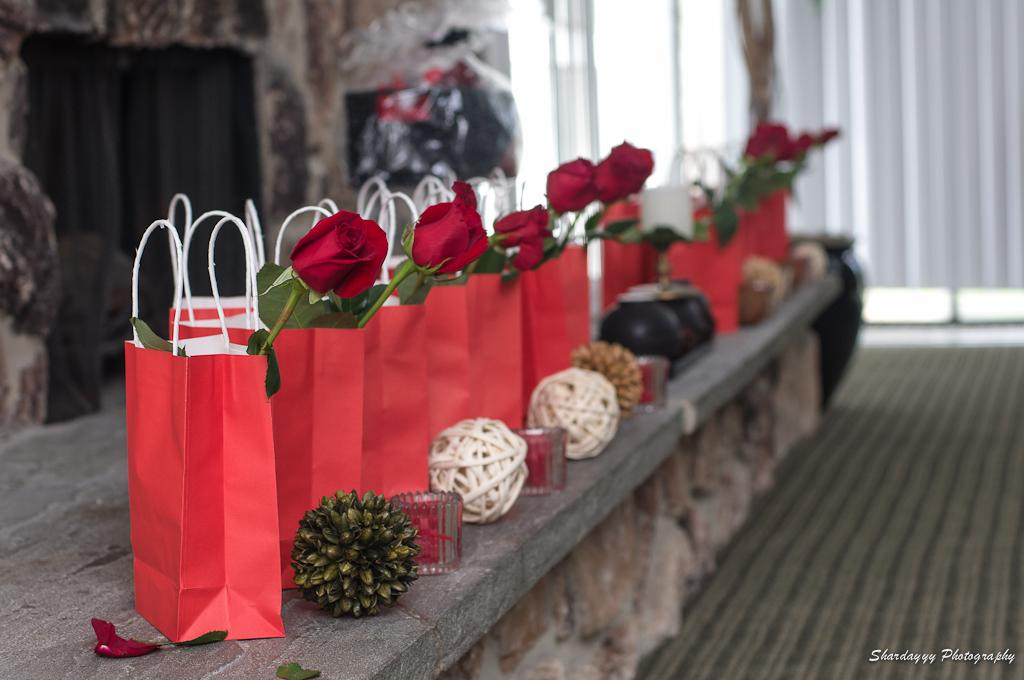What objects are present in the image that are used for carrying items? There are bags in the image. What decorative elements can be seen inside the bags? The bags have flowers in them. What type of objects are round and visible in the image? There are balls in the image. What objects are present in the image that provide light? There are candles in the image. What type of window treatment is visible in the image? There is a curtain in the image. What type of floor covering is visible in the image? There is a carpet in the image. What type of structure is being built in the image? There is no structure being built in the image; the focus is on the bags, flowers, balls, candles, curtain, and carpet. 